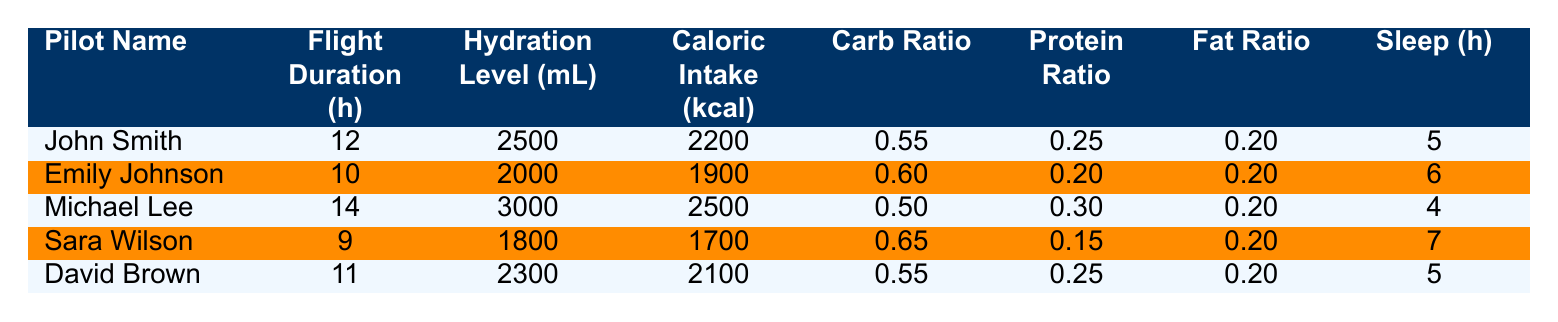What is the hydration level of Michael Lee? The hydration level for Michael Lee is found in the table under his name, listed as 3000 mL.
Answer: 3000 mL Who had the longest flight duration? To determine the longest flight, we compare the flight durations in the table. Michael Lee has a flight duration of 14 hours, which is the highest listed.
Answer: Michael Lee What is the total caloric intake of pilots whose flight duration is 10 hours or more? The pilots with flight duration of 10 hours or more are John Smith (2200 kcal), Michael Lee (2500 kcal), David Brown (2100 kcal), and Emily Johnson (1900 kcal). Adding these values gives 2200 + 2500 + 2100 + 1900 = 10700 kcal.
Answer: 10700 kcal Is Sara Wilson's carbohydrate ratio higher than John's? Sara Wilson has a carbohydrate ratio of 0.65 while John Smith's carbohydrate ratio is 0.55. Since 0.65 is greater than 0.55, the statement is true.
Answer: Yes What is the average sleep duration of all pilots? To find the average sleep duration, we add the sleep hours of all pilots: 5 + 6 + 4 + 7 + 5 = 27 hours. There are 5 pilots, so the average sleep duration is 27 / 5 = 5.4 hours.
Answer: 5.4 hours Which pilot had a hydration level below 2000 mL? We can look at the hydration levels for each pilot in the table. Both Emily Johnson (2000 mL) and Sara Wilson (1800 mL) have hydration levels below 2000 mL, but only Sara Wilson is below that threshold.
Answer: Sara Wilson What is the difference in caloric intake between the pilot with the highest and lowest caloric intake? The highest caloric intake is from Michael Lee with 2500 kcal and the lowest is from Sara Wilson with 1700 kcal. The difference is 2500 - 1700 = 800 kcal.
Answer: 800 kcal Do all pilots have a fat ratio of 0.20? By examining the fat ratios in the table: John Smith (0.20), Emily Johnson (0.20), Michael Lee (0.20), Sara Wilson (0.20), and David Brown (0.20), it shows that all pilots indeed have a fat ratio of 0.20.
Answer: Yes 